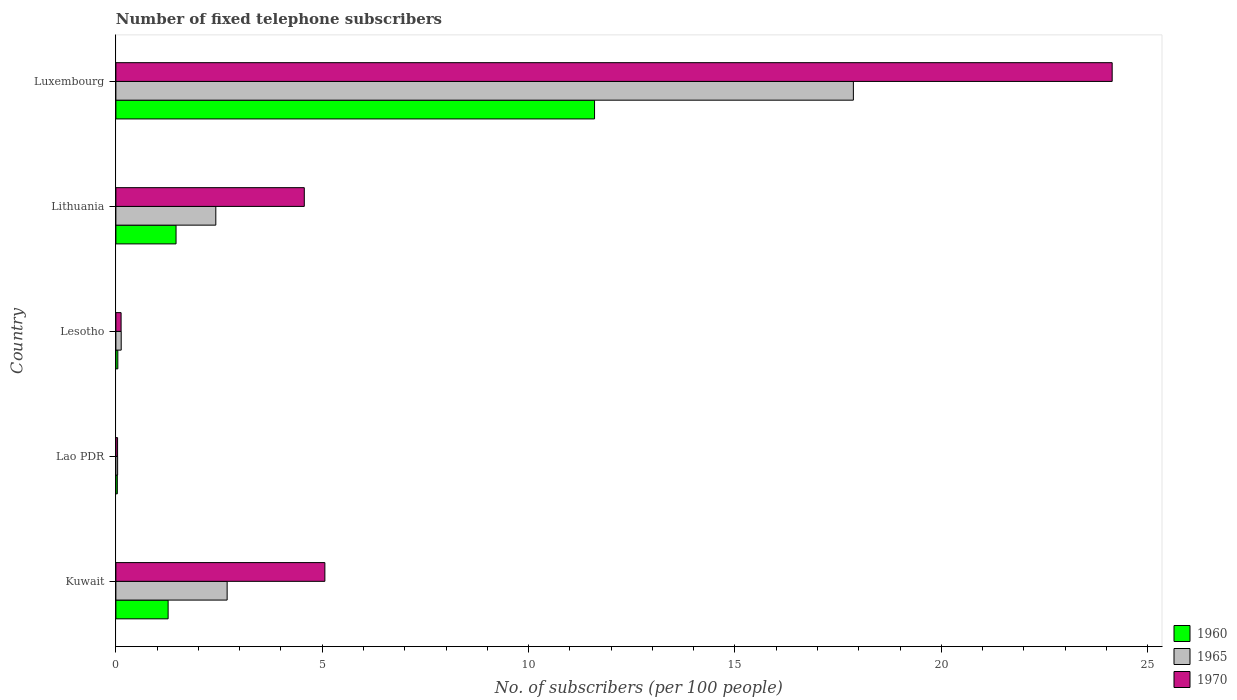How many groups of bars are there?
Offer a very short reply. 5. Are the number of bars on each tick of the Y-axis equal?
Provide a short and direct response. Yes. How many bars are there on the 5th tick from the bottom?
Provide a succinct answer. 3. What is the label of the 3rd group of bars from the top?
Your answer should be compact. Lesotho. What is the number of fixed telephone subscribers in 1965 in Kuwait?
Make the answer very short. 2.7. Across all countries, what is the maximum number of fixed telephone subscribers in 1970?
Your answer should be very brief. 24.14. Across all countries, what is the minimum number of fixed telephone subscribers in 1960?
Your answer should be very brief. 0.03. In which country was the number of fixed telephone subscribers in 1960 maximum?
Provide a succinct answer. Luxembourg. In which country was the number of fixed telephone subscribers in 1970 minimum?
Your response must be concise. Lao PDR. What is the total number of fixed telephone subscribers in 1960 in the graph?
Your answer should be very brief. 14.4. What is the difference between the number of fixed telephone subscribers in 1965 in Lao PDR and that in Lithuania?
Ensure brevity in your answer.  -2.38. What is the difference between the number of fixed telephone subscribers in 1960 in Luxembourg and the number of fixed telephone subscribers in 1965 in Lithuania?
Provide a succinct answer. 9.18. What is the average number of fixed telephone subscribers in 1970 per country?
Your answer should be compact. 6.79. What is the difference between the number of fixed telephone subscribers in 1965 and number of fixed telephone subscribers in 1970 in Luxembourg?
Your response must be concise. -6.27. What is the ratio of the number of fixed telephone subscribers in 1965 in Kuwait to that in Lao PDR?
Provide a succinct answer. 64.17. Is the number of fixed telephone subscribers in 1965 in Lao PDR less than that in Lithuania?
Offer a very short reply. Yes. Is the difference between the number of fixed telephone subscribers in 1965 in Lao PDR and Lesotho greater than the difference between the number of fixed telephone subscribers in 1970 in Lao PDR and Lesotho?
Ensure brevity in your answer.  No. What is the difference between the highest and the second highest number of fixed telephone subscribers in 1965?
Give a very brief answer. 15.17. What is the difference between the highest and the lowest number of fixed telephone subscribers in 1960?
Your answer should be very brief. 11.56. In how many countries, is the number of fixed telephone subscribers in 1965 greater than the average number of fixed telephone subscribers in 1965 taken over all countries?
Make the answer very short. 1. Is the sum of the number of fixed telephone subscribers in 1965 in Lesotho and Luxembourg greater than the maximum number of fixed telephone subscribers in 1970 across all countries?
Ensure brevity in your answer.  No. What does the 2nd bar from the top in Kuwait represents?
Offer a very short reply. 1965. What does the 2nd bar from the bottom in Lao PDR represents?
Give a very brief answer. 1965. Is it the case that in every country, the sum of the number of fixed telephone subscribers in 1970 and number of fixed telephone subscribers in 1960 is greater than the number of fixed telephone subscribers in 1965?
Provide a succinct answer. Yes. How many bars are there?
Ensure brevity in your answer.  15. Are all the bars in the graph horizontal?
Your answer should be compact. Yes. Are the values on the major ticks of X-axis written in scientific E-notation?
Make the answer very short. No. Does the graph contain grids?
Keep it short and to the point. No. How are the legend labels stacked?
Your answer should be very brief. Vertical. What is the title of the graph?
Make the answer very short. Number of fixed telephone subscribers. Does "1987" appear as one of the legend labels in the graph?
Your answer should be very brief. No. What is the label or title of the X-axis?
Your answer should be very brief. No. of subscribers (per 100 people). What is the label or title of the Y-axis?
Keep it short and to the point. Country. What is the No. of subscribers (per 100 people) of 1960 in Kuwait?
Offer a very short reply. 1.27. What is the No. of subscribers (per 100 people) of 1965 in Kuwait?
Provide a short and direct response. 2.7. What is the No. of subscribers (per 100 people) of 1970 in Kuwait?
Offer a very short reply. 5.06. What is the No. of subscribers (per 100 people) in 1960 in Lao PDR?
Your answer should be very brief. 0.03. What is the No. of subscribers (per 100 people) of 1965 in Lao PDR?
Your response must be concise. 0.04. What is the No. of subscribers (per 100 people) in 1970 in Lao PDR?
Ensure brevity in your answer.  0.04. What is the No. of subscribers (per 100 people) of 1960 in Lesotho?
Keep it short and to the point. 0.05. What is the No. of subscribers (per 100 people) in 1965 in Lesotho?
Your response must be concise. 0.13. What is the No. of subscribers (per 100 people) in 1970 in Lesotho?
Provide a short and direct response. 0.13. What is the No. of subscribers (per 100 people) in 1960 in Lithuania?
Your answer should be very brief. 1.46. What is the No. of subscribers (per 100 people) of 1965 in Lithuania?
Provide a succinct answer. 2.42. What is the No. of subscribers (per 100 people) in 1970 in Lithuania?
Offer a terse response. 4.57. What is the No. of subscribers (per 100 people) of 1960 in Luxembourg?
Make the answer very short. 11.6. What is the No. of subscribers (per 100 people) in 1965 in Luxembourg?
Offer a terse response. 17.87. What is the No. of subscribers (per 100 people) of 1970 in Luxembourg?
Your answer should be very brief. 24.14. Across all countries, what is the maximum No. of subscribers (per 100 people) in 1960?
Provide a short and direct response. 11.6. Across all countries, what is the maximum No. of subscribers (per 100 people) in 1965?
Offer a very short reply. 17.87. Across all countries, what is the maximum No. of subscribers (per 100 people) of 1970?
Offer a terse response. 24.14. Across all countries, what is the minimum No. of subscribers (per 100 people) in 1960?
Offer a very short reply. 0.03. Across all countries, what is the minimum No. of subscribers (per 100 people) in 1965?
Your response must be concise. 0.04. Across all countries, what is the minimum No. of subscribers (per 100 people) of 1970?
Ensure brevity in your answer.  0.04. What is the total No. of subscribers (per 100 people) of 1960 in the graph?
Make the answer very short. 14.4. What is the total No. of subscribers (per 100 people) of 1965 in the graph?
Give a very brief answer. 23.16. What is the total No. of subscribers (per 100 people) in 1970 in the graph?
Give a very brief answer. 33.94. What is the difference between the No. of subscribers (per 100 people) of 1960 in Kuwait and that in Lao PDR?
Your response must be concise. 1.23. What is the difference between the No. of subscribers (per 100 people) in 1965 in Kuwait and that in Lao PDR?
Ensure brevity in your answer.  2.65. What is the difference between the No. of subscribers (per 100 people) in 1970 in Kuwait and that in Lao PDR?
Offer a very short reply. 5.02. What is the difference between the No. of subscribers (per 100 people) of 1960 in Kuwait and that in Lesotho?
Keep it short and to the point. 1.22. What is the difference between the No. of subscribers (per 100 people) of 1965 in Kuwait and that in Lesotho?
Provide a succinct answer. 2.57. What is the difference between the No. of subscribers (per 100 people) in 1970 in Kuwait and that in Lesotho?
Your answer should be compact. 4.94. What is the difference between the No. of subscribers (per 100 people) of 1960 in Kuwait and that in Lithuania?
Make the answer very short. -0.19. What is the difference between the No. of subscribers (per 100 people) of 1965 in Kuwait and that in Lithuania?
Keep it short and to the point. 0.27. What is the difference between the No. of subscribers (per 100 people) in 1970 in Kuwait and that in Lithuania?
Your answer should be compact. 0.5. What is the difference between the No. of subscribers (per 100 people) of 1960 in Kuwait and that in Luxembourg?
Make the answer very short. -10.33. What is the difference between the No. of subscribers (per 100 people) in 1965 in Kuwait and that in Luxembourg?
Offer a terse response. -15.17. What is the difference between the No. of subscribers (per 100 people) in 1970 in Kuwait and that in Luxembourg?
Provide a short and direct response. -19.08. What is the difference between the No. of subscribers (per 100 people) in 1960 in Lao PDR and that in Lesotho?
Provide a succinct answer. -0.01. What is the difference between the No. of subscribers (per 100 people) of 1965 in Lao PDR and that in Lesotho?
Make the answer very short. -0.09. What is the difference between the No. of subscribers (per 100 people) in 1970 in Lao PDR and that in Lesotho?
Provide a succinct answer. -0.09. What is the difference between the No. of subscribers (per 100 people) of 1960 in Lao PDR and that in Lithuania?
Provide a succinct answer. -1.42. What is the difference between the No. of subscribers (per 100 people) in 1965 in Lao PDR and that in Lithuania?
Your answer should be very brief. -2.38. What is the difference between the No. of subscribers (per 100 people) of 1970 in Lao PDR and that in Lithuania?
Provide a succinct answer. -4.52. What is the difference between the No. of subscribers (per 100 people) in 1960 in Lao PDR and that in Luxembourg?
Your response must be concise. -11.56. What is the difference between the No. of subscribers (per 100 people) in 1965 in Lao PDR and that in Luxembourg?
Provide a short and direct response. -17.83. What is the difference between the No. of subscribers (per 100 people) of 1970 in Lao PDR and that in Luxembourg?
Provide a succinct answer. -24.1. What is the difference between the No. of subscribers (per 100 people) of 1960 in Lesotho and that in Lithuania?
Provide a short and direct response. -1.41. What is the difference between the No. of subscribers (per 100 people) in 1965 in Lesotho and that in Lithuania?
Give a very brief answer. -2.29. What is the difference between the No. of subscribers (per 100 people) in 1970 in Lesotho and that in Lithuania?
Make the answer very short. -4.44. What is the difference between the No. of subscribers (per 100 people) of 1960 in Lesotho and that in Luxembourg?
Offer a very short reply. -11.55. What is the difference between the No. of subscribers (per 100 people) of 1965 in Lesotho and that in Luxembourg?
Keep it short and to the point. -17.74. What is the difference between the No. of subscribers (per 100 people) of 1970 in Lesotho and that in Luxembourg?
Ensure brevity in your answer.  -24.01. What is the difference between the No. of subscribers (per 100 people) of 1960 in Lithuania and that in Luxembourg?
Keep it short and to the point. -10.14. What is the difference between the No. of subscribers (per 100 people) in 1965 in Lithuania and that in Luxembourg?
Make the answer very short. -15.45. What is the difference between the No. of subscribers (per 100 people) in 1970 in Lithuania and that in Luxembourg?
Your answer should be very brief. -19.58. What is the difference between the No. of subscribers (per 100 people) in 1960 in Kuwait and the No. of subscribers (per 100 people) in 1965 in Lao PDR?
Offer a terse response. 1.22. What is the difference between the No. of subscribers (per 100 people) in 1960 in Kuwait and the No. of subscribers (per 100 people) in 1970 in Lao PDR?
Your answer should be very brief. 1.22. What is the difference between the No. of subscribers (per 100 people) of 1965 in Kuwait and the No. of subscribers (per 100 people) of 1970 in Lao PDR?
Provide a succinct answer. 2.65. What is the difference between the No. of subscribers (per 100 people) of 1960 in Kuwait and the No. of subscribers (per 100 people) of 1965 in Lesotho?
Keep it short and to the point. 1.14. What is the difference between the No. of subscribers (per 100 people) in 1960 in Kuwait and the No. of subscribers (per 100 people) in 1970 in Lesotho?
Offer a very short reply. 1.14. What is the difference between the No. of subscribers (per 100 people) of 1965 in Kuwait and the No. of subscribers (per 100 people) of 1970 in Lesotho?
Provide a succinct answer. 2.57. What is the difference between the No. of subscribers (per 100 people) in 1960 in Kuwait and the No. of subscribers (per 100 people) in 1965 in Lithuania?
Keep it short and to the point. -1.16. What is the difference between the No. of subscribers (per 100 people) in 1960 in Kuwait and the No. of subscribers (per 100 people) in 1970 in Lithuania?
Offer a very short reply. -3.3. What is the difference between the No. of subscribers (per 100 people) of 1965 in Kuwait and the No. of subscribers (per 100 people) of 1970 in Lithuania?
Offer a terse response. -1.87. What is the difference between the No. of subscribers (per 100 people) in 1960 in Kuwait and the No. of subscribers (per 100 people) in 1965 in Luxembourg?
Provide a succinct answer. -16.6. What is the difference between the No. of subscribers (per 100 people) of 1960 in Kuwait and the No. of subscribers (per 100 people) of 1970 in Luxembourg?
Provide a short and direct response. -22.88. What is the difference between the No. of subscribers (per 100 people) of 1965 in Kuwait and the No. of subscribers (per 100 people) of 1970 in Luxembourg?
Your response must be concise. -21.44. What is the difference between the No. of subscribers (per 100 people) of 1960 in Lao PDR and the No. of subscribers (per 100 people) of 1965 in Lesotho?
Provide a short and direct response. -0.09. What is the difference between the No. of subscribers (per 100 people) of 1960 in Lao PDR and the No. of subscribers (per 100 people) of 1970 in Lesotho?
Your response must be concise. -0.09. What is the difference between the No. of subscribers (per 100 people) in 1965 in Lao PDR and the No. of subscribers (per 100 people) in 1970 in Lesotho?
Make the answer very short. -0.08. What is the difference between the No. of subscribers (per 100 people) of 1960 in Lao PDR and the No. of subscribers (per 100 people) of 1965 in Lithuania?
Ensure brevity in your answer.  -2.39. What is the difference between the No. of subscribers (per 100 people) of 1960 in Lao PDR and the No. of subscribers (per 100 people) of 1970 in Lithuania?
Provide a succinct answer. -4.53. What is the difference between the No. of subscribers (per 100 people) of 1965 in Lao PDR and the No. of subscribers (per 100 people) of 1970 in Lithuania?
Your response must be concise. -4.52. What is the difference between the No. of subscribers (per 100 people) in 1960 in Lao PDR and the No. of subscribers (per 100 people) in 1965 in Luxembourg?
Your answer should be compact. -17.84. What is the difference between the No. of subscribers (per 100 people) of 1960 in Lao PDR and the No. of subscribers (per 100 people) of 1970 in Luxembourg?
Make the answer very short. -24.11. What is the difference between the No. of subscribers (per 100 people) in 1965 in Lao PDR and the No. of subscribers (per 100 people) in 1970 in Luxembourg?
Provide a short and direct response. -24.1. What is the difference between the No. of subscribers (per 100 people) of 1960 in Lesotho and the No. of subscribers (per 100 people) of 1965 in Lithuania?
Your answer should be very brief. -2.37. What is the difference between the No. of subscribers (per 100 people) in 1960 in Lesotho and the No. of subscribers (per 100 people) in 1970 in Lithuania?
Your answer should be very brief. -4.52. What is the difference between the No. of subscribers (per 100 people) in 1965 in Lesotho and the No. of subscribers (per 100 people) in 1970 in Lithuania?
Offer a terse response. -4.44. What is the difference between the No. of subscribers (per 100 people) in 1960 in Lesotho and the No. of subscribers (per 100 people) in 1965 in Luxembourg?
Give a very brief answer. -17.82. What is the difference between the No. of subscribers (per 100 people) in 1960 in Lesotho and the No. of subscribers (per 100 people) in 1970 in Luxembourg?
Offer a terse response. -24.09. What is the difference between the No. of subscribers (per 100 people) of 1965 in Lesotho and the No. of subscribers (per 100 people) of 1970 in Luxembourg?
Ensure brevity in your answer.  -24.01. What is the difference between the No. of subscribers (per 100 people) in 1960 in Lithuania and the No. of subscribers (per 100 people) in 1965 in Luxembourg?
Your answer should be very brief. -16.41. What is the difference between the No. of subscribers (per 100 people) in 1960 in Lithuania and the No. of subscribers (per 100 people) in 1970 in Luxembourg?
Your response must be concise. -22.68. What is the difference between the No. of subscribers (per 100 people) of 1965 in Lithuania and the No. of subscribers (per 100 people) of 1970 in Luxembourg?
Your answer should be compact. -21.72. What is the average No. of subscribers (per 100 people) of 1960 per country?
Give a very brief answer. 2.88. What is the average No. of subscribers (per 100 people) of 1965 per country?
Your answer should be very brief. 4.63. What is the average No. of subscribers (per 100 people) in 1970 per country?
Your response must be concise. 6.79. What is the difference between the No. of subscribers (per 100 people) of 1960 and No. of subscribers (per 100 people) of 1965 in Kuwait?
Offer a terse response. -1.43. What is the difference between the No. of subscribers (per 100 people) in 1960 and No. of subscribers (per 100 people) in 1970 in Kuwait?
Provide a succinct answer. -3.8. What is the difference between the No. of subscribers (per 100 people) in 1965 and No. of subscribers (per 100 people) in 1970 in Kuwait?
Ensure brevity in your answer.  -2.37. What is the difference between the No. of subscribers (per 100 people) of 1960 and No. of subscribers (per 100 people) of 1965 in Lao PDR?
Make the answer very short. -0.01. What is the difference between the No. of subscribers (per 100 people) in 1960 and No. of subscribers (per 100 people) in 1970 in Lao PDR?
Keep it short and to the point. -0.01. What is the difference between the No. of subscribers (per 100 people) of 1965 and No. of subscribers (per 100 people) of 1970 in Lao PDR?
Your answer should be compact. 0. What is the difference between the No. of subscribers (per 100 people) in 1960 and No. of subscribers (per 100 people) in 1965 in Lesotho?
Your answer should be very brief. -0.08. What is the difference between the No. of subscribers (per 100 people) in 1960 and No. of subscribers (per 100 people) in 1970 in Lesotho?
Offer a terse response. -0.08. What is the difference between the No. of subscribers (per 100 people) in 1965 and No. of subscribers (per 100 people) in 1970 in Lesotho?
Provide a succinct answer. 0. What is the difference between the No. of subscribers (per 100 people) of 1960 and No. of subscribers (per 100 people) of 1965 in Lithuania?
Offer a very short reply. -0.96. What is the difference between the No. of subscribers (per 100 people) in 1960 and No. of subscribers (per 100 people) in 1970 in Lithuania?
Offer a terse response. -3.11. What is the difference between the No. of subscribers (per 100 people) in 1965 and No. of subscribers (per 100 people) in 1970 in Lithuania?
Ensure brevity in your answer.  -2.14. What is the difference between the No. of subscribers (per 100 people) of 1960 and No. of subscribers (per 100 people) of 1965 in Luxembourg?
Make the answer very short. -6.27. What is the difference between the No. of subscribers (per 100 people) in 1960 and No. of subscribers (per 100 people) in 1970 in Luxembourg?
Your answer should be compact. -12.54. What is the difference between the No. of subscribers (per 100 people) of 1965 and No. of subscribers (per 100 people) of 1970 in Luxembourg?
Offer a terse response. -6.27. What is the ratio of the No. of subscribers (per 100 people) in 1960 in Kuwait to that in Lao PDR?
Offer a terse response. 36.45. What is the ratio of the No. of subscribers (per 100 people) of 1965 in Kuwait to that in Lao PDR?
Give a very brief answer. 64.17. What is the ratio of the No. of subscribers (per 100 people) in 1970 in Kuwait to that in Lao PDR?
Offer a very short reply. 123.61. What is the ratio of the No. of subscribers (per 100 people) in 1960 in Kuwait to that in Lesotho?
Keep it short and to the point. 26.94. What is the ratio of the No. of subscribers (per 100 people) of 1965 in Kuwait to that in Lesotho?
Make the answer very short. 20.96. What is the ratio of the No. of subscribers (per 100 people) in 1970 in Kuwait to that in Lesotho?
Provide a succinct answer. 40.21. What is the ratio of the No. of subscribers (per 100 people) of 1960 in Kuwait to that in Lithuania?
Your response must be concise. 0.87. What is the ratio of the No. of subscribers (per 100 people) in 1965 in Kuwait to that in Lithuania?
Make the answer very short. 1.11. What is the ratio of the No. of subscribers (per 100 people) in 1970 in Kuwait to that in Lithuania?
Keep it short and to the point. 1.11. What is the ratio of the No. of subscribers (per 100 people) of 1960 in Kuwait to that in Luxembourg?
Offer a very short reply. 0.11. What is the ratio of the No. of subscribers (per 100 people) in 1965 in Kuwait to that in Luxembourg?
Offer a terse response. 0.15. What is the ratio of the No. of subscribers (per 100 people) in 1970 in Kuwait to that in Luxembourg?
Offer a very short reply. 0.21. What is the ratio of the No. of subscribers (per 100 people) of 1960 in Lao PDR to that in Lesotho?
Offer a terse response. 0.74. What is the ratio of the No. of subscribers (per 100 people) in 1965 in Lao PDR to that in Lesotho?
Offer a very short reply. 0.33. What is the ratio of the No. of subscribers (per 100 people) in 1970 in Lao PDR to that in Lesotho?
Offer a very short reply. 0.33. What is the ratio of the No. of subscribers (per 100 people) in 1960 in Lao PDR to that in Lithuania?
Your answer should be compact. 0.02. What is the ratio of the No. of subscribers (per 100 people) in 1965 in Lao PDR to that in Lithuania?
Offer a very short reply. 0.02. What is the ratio of the No. of subscribers (per 100 people) in 1970 in Lao PDR to that in Lithuania?
Offer a very short reply. 0.01. What is the ratio of the No. of subscribers (per 100 people) of 1960 in Lao PDR to that in Luxembourg?
Your answer should be very brief. 0. What is the ratio of the No. of subscribers (per 100 people) in 1965 in Lao PDR to that in Luxembourg?
Your response must be concise. 0. What is the ratio of the No. of subscribers (per 100 people) of 1970 in Lao PDR to that in Luxembourg?
Keep it short and to the point. 0. What is the ratio of the No. of subscribers (per 100 people) in 1960 in Lesotho to that in Lithuania?
Provide a short and direct response. 0.03. What is the ratio of the No. of subscribers (per 100 people) of 1965 in Lesotho to that in Lithuania?
Keep it short and to the point. 0.05. What is the ratio of the No. of subscribers (per 100 people) in 1970 in Lesotho to that in Lithuania?
Offer a terse response. 0.03. What is the ratio of the No. of subscribers (per 100 people) of 1960 in Lesotho to that in Luxembourg?
Provide a succinct answer. 0. What is the ratio of the No. of subscribers (per 100 people) of 1965 in Lesotho to that in Luxembourg?
Provide a short and direct response. 0.01. What is the ratio of the No. of subscribers (per 100 people) in 1970 in Lesotho to that in Luxembourg?
Offer a very short reply. 0.01. What is the ratio of the No. of subscribers (per 100 people) of 1960 in Lithuania to that in Luxembourg?
Give a very brief answer. 0.13. What is the ratio of the No. of subscribers (per 100 people) of 1965 in Lithuania to that in Luxembourg?
Offer a very short reply. 0.14. What is the ratio of the No. of subscribers (per 100 people) in 1970 in Lithuania to that in Luxembourg?
Provide a short and direct response. 0.19. What is the difference between the highest and the second highest No. of subscribers (per 100 people) of 1960?
Provide a short and direct response. 10.14. What is the difference between the highest and the second highest No. of subscribers (per 100 people) in 1965?
Your response must be concise. 15.17. What is the difference between the highest and the second highest No. of subscribers (per 100 people) in 1970?
Ensure brevity in your answer.  19.08. What is the difference between the highest and the lowest No. of subscribers (per 100 people) of 1960?
Provide a succinct answer. 11.56. What is the difference between the highest and the lowest No. of subscribers (per 100 people) in 1965?
Provide a succinct answer. 17.83. What is the difference between the highest and the lowest No. of subscribers (per 100 people) of 1970?
Offer a very short reply. 24.1. 